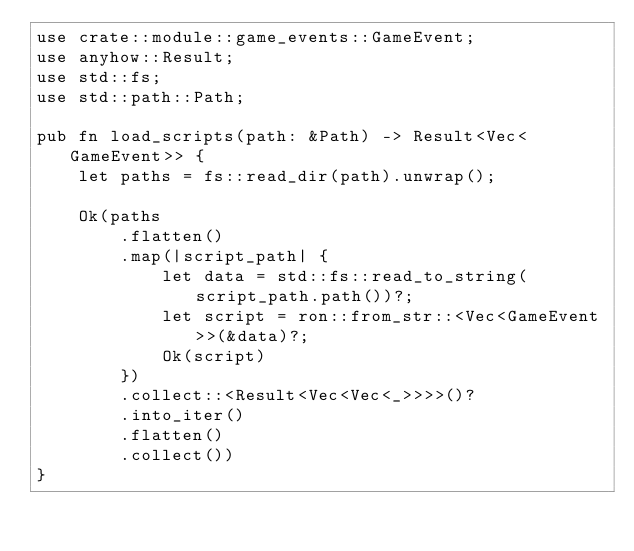Convert code to text. <code><loc_0><loc_0><loc_500><loc_500><_Rust_>use crate::module::game_events::GameEvent;
use anyhow::Result;
use std::fs;
use std::path::Path;

pub fn load_scripts(path: &Path) -> Result<Vec<GameEvent>> {
    let paths = fs::read_dir(path).unwrap();

    Ok(paths
        .flatten()
        .map(|script_path| {
            let data = std::fs::read_to_string(script_path.path())?;
            let script = ron::from_str::<Vec<GameEvent>>(&data)?;
            Ok(script)
        })
        .collect::<Result<Vec<Vec<_>>>>()?
        .into_iter()
        .flatten()
        .collect())
}
</code> 